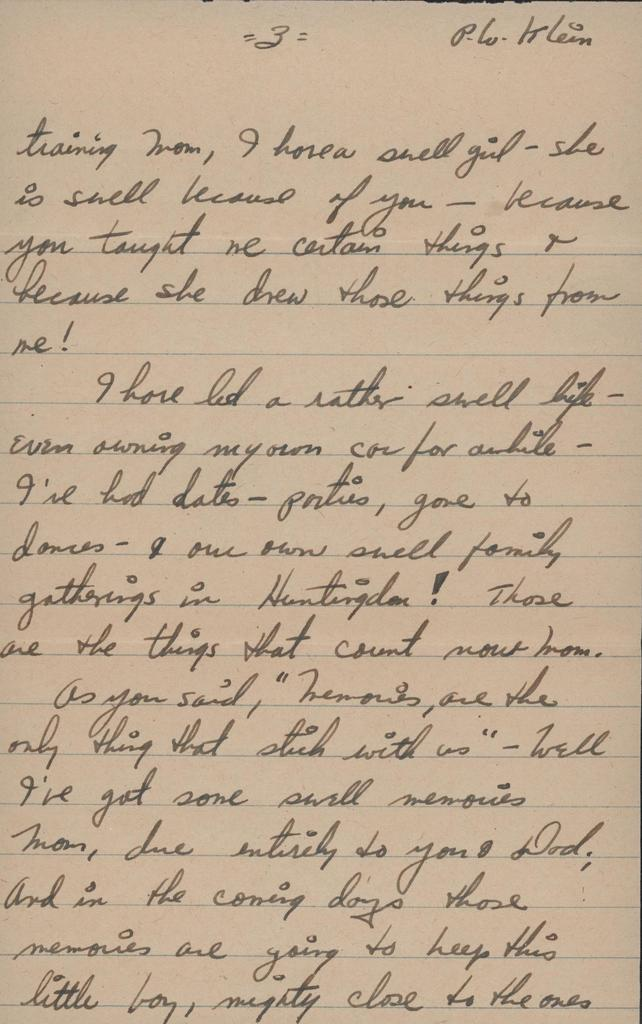<image>
Render a clear and concise summary of the photo. A letter written in cursive by P.W Klein. 